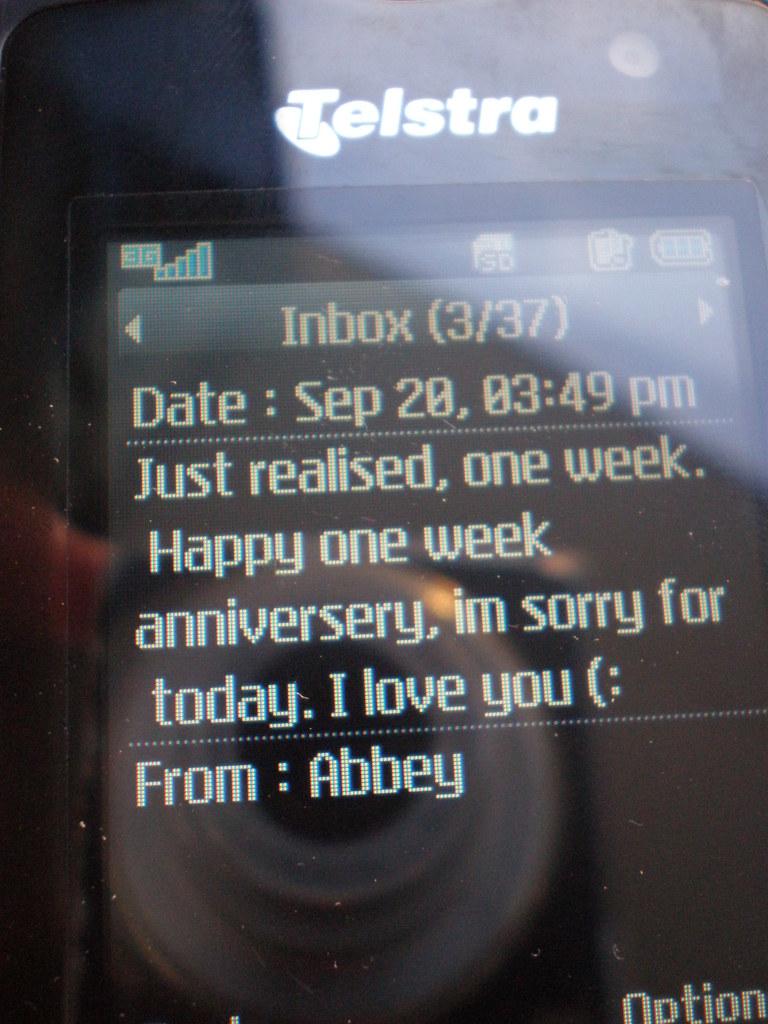Who is this message from?
Give a very brief answer. Abbey. When was this sent?
Keep it short and to the point. Sep 20, 03:49 pm. 